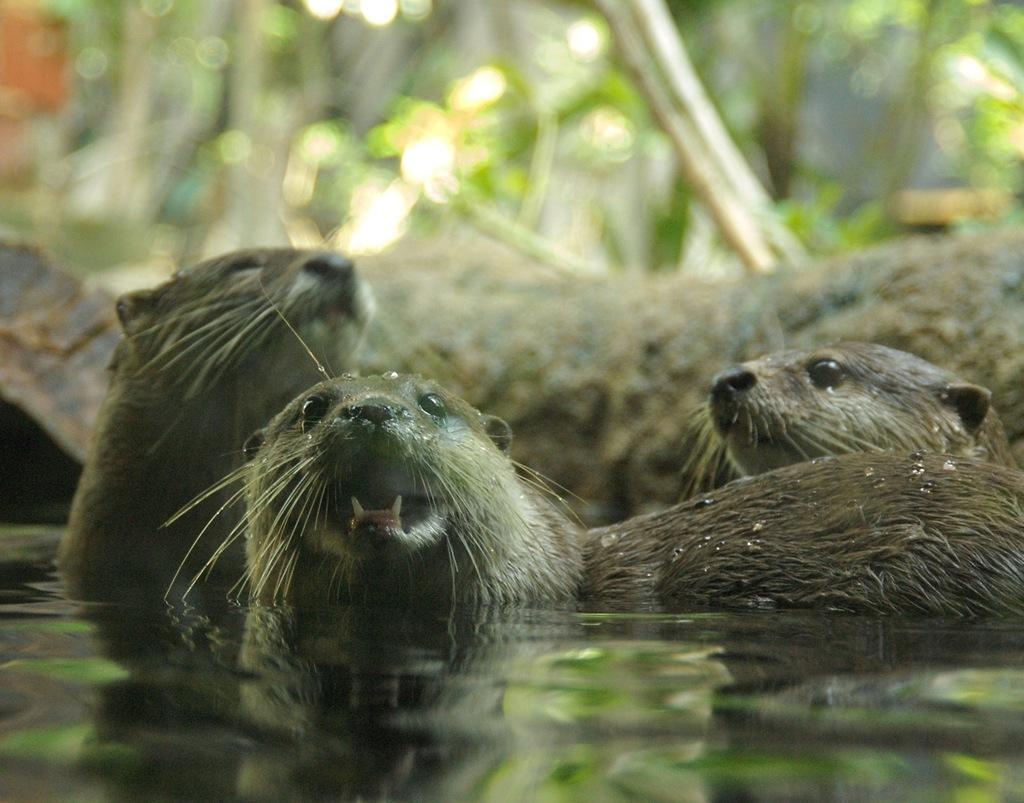Can you describe this image briefly? In this picture there are seals in the water. At the back there are trees. 